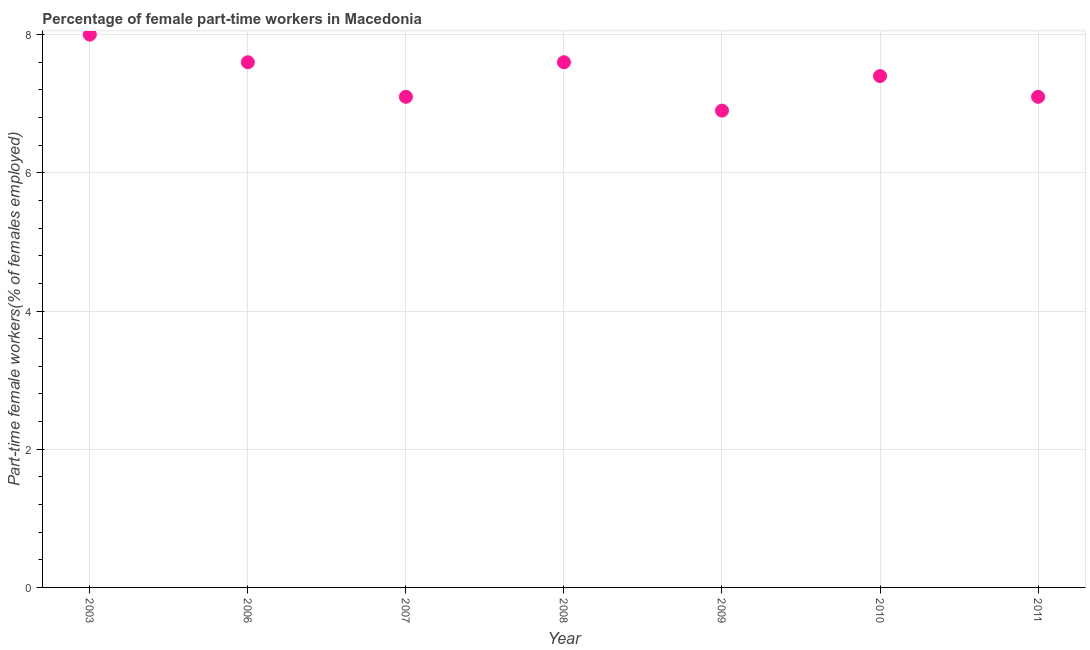What is the percentage of part-time female workers in 2010?
Your answer should be very brief. 7.4. Across all years, what is the minimum percentage of part-time female workers?
Provide a short and direct response. 6.9. What is the sum of the percentage of part-time female workers?
Provide a short and direct response. 51.7. What is the difference between the percentage of part-time female workers in 2008 and 2010?
Provide a short and direct response. 0.2. What is the average percentage of part-time female workers per year?
Keep it short and to the point. 7.39. What is the median percentage of part-time female workers?
Your answer should be very brief. 7.4. In how many years, is the percentage of part-time female workers greater than 6.8 %?
Ensure brevity in your answer.  7. Do a majority of the years between 2006 and 2008 (inclusive) have percentage of part-time female workers greater than 5.2 %?
Make the answer very short. Yes. What is the ratio of the percentage of part-time female workers in 2006 to that in 2011?
Make the answer very short. 1.07. Is the percentage of part-time female workers in 2006 less than that in 2008?
Offer a terse response. No. What is the difference between the highest and the second highest percentage of part-time female workers?
Keep it short and to the point. 0.4. Is the sum of the percentage of part-time female workers in 2007 and 2008 greater than the maximum percentage of part-time female workers across all years?
Make the answer very short. Yes. What is the difference between the highest and the lowest percentage of part-time female workers?
Provide a short and direct response. 1.1. Does the percentage of part-time female workers monotonically increase over the years?
Keep it short and to the point. No. How many years are there in the graph?
Your answer should be very brief. 7. What is the difference between two consecutive major ticks on the Y-axis?
Your answer should be very brief. 2. What is the title of the graph?
Provide a short and direct response. Percentage of female part-time workers in Macedonia. What is the label or title of the X-axis?
Make the answer very short. Year. What is the label or title of the Y-axis?
Your response must be concise. Part-time female workers(% of females employed). What is the Part-time female workers(% of females employed) in 2003?
Your answer should be very brief. 8. What is the Part-time female workers(% of females employed) in 2006?
Your answer should be very brief. 7.6. What is the Part-time female workers(% of females employed) in 2007?
Offer a very short reply. 7.1. What is the Part-time female workers(% of females employed) in 2008?
Your answer should be compact. 7.6. What is the Part-time female workers(% of females employed) in 2009?
Provide a succinct answer. 6.9. What is the Part-time female workers(% of females employed) in 2010?
Ensure brevity in your answer.  7.4. What is the Part-time female workers(% of females employed) in 2011?
Ensure brevity in your answer.  7.1. What is the difference between the Part-time female workers(% of females employed) in 2003 and 2006?
Make the answer very short. 0.4. What is the difference between the Part-time female workers(% of females employed) in 2003 and 2007?
Your answer should be very brief. 0.9. What is the difference between the Part-time female workers(% of females employed) in 2003 and 2009?
Offer a terse response. 1.1. What is the difference between the Part-time female workers(% of females employed) in 2006 and 2007?
Ensure brevity in your answer.  0.5. What is the difference between the Part-time female workers(% of females employed) in 2006 and 2009?
Provide a succinct answer. 0.7. What is the difference between the Part-time female workers(% of females employed) in 2006 and 2010?
Make the answer very short. 0.2. What is the difference between the Part-time female workers(% of females employed) in 2007 and 2008?
Offer a terse response. -0.5. What is the difference between the Part-time female workers(% of females employed) in 2007 and 2009?
Make the answer very short. 0.2. What is the difference between the Part-time female workers(% of females employed) in 2009 and 2011?
Ensure brevity in your answer.  -0.2. What is the ratio of the Part-time female workers(% of females employed) in 2003 to that in 2006?
Your response must be concise. 1.05. What is the ratio of the Part-time female workers(% of females employed) in 2003 to that in 2007?
Your response must be concise. 1.13. What is the ratio of the Part-time female workers(% of females employed) in 2003 to that in 2008?
Your answer should be compact. 1.05. What is the ratio of the Part-time female workers(% of females employed) in 2003 to that in 2009?
Your response must be concise. 1.16. What is the ratio of the Part-time female workers(% of females employed) in 2003 to that in 2010?
Offer a very short reply. 1.08. What is the ratio of the Part-time female workers(% of females employed) in 2003 to that in 2011?
Offer a terse response. 1.13. What is the ratio of the Part-time female workers(% of females employed) in 2006 to that in 2007?
Ensure brevity in your answer.  1.07. What is the ratio of the Part-time female workers(% of females employed) in 2006 to that in 2008?
Provide a succinct answer. 1. What is the ratio of the Part-time female workers(% of females employed) in 2006 to that in 2009?
Your answer should be very brief. 1.1. What is the ratio of the Part-time female workers(% of females employed) in 2006 to that in 2010?
Provide a short and direct response. 1.03. What is the ratio of the Part-time female workers(% of females employed) in 2006 to that in 2011?
Ensure brevity in your answer.  1.07. What is the ratio of the Part-time female workers(% of females employed) in 2007 to that in 2008?
Offer a very short reply. 0.93. What is the ratio of the Part-time female workers(% of females employed) in 2007 to that in 2009?
Your answer should be very brief. 1.03. What is the ratio of the Part-time female workers(% of females employed) in 2008 to that in 2009?
Your answer should be compact. 1.1. What is the ratio of the Part-time female workers(% of females employed) in 2008 to that in 2011?
Your answer should be very brief. 1.07. What is the ratio of the Part-time female workers(% of females employed) in 2009 to that in 2010?
Offer a terse response. 0.93. What is the ratio of the Part-time female workers(% of females employed) in 2010 to that in 2011?
Make the answer very short. 1.04. 